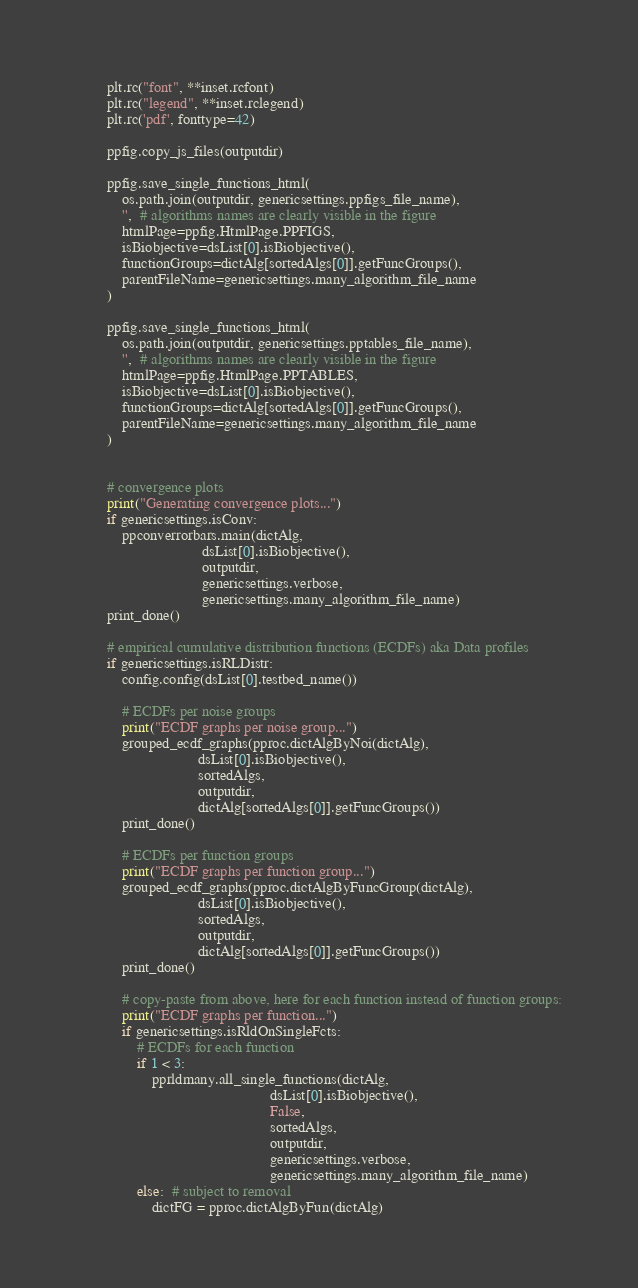<code> <loc_0><loc_0><loc_500><loc_500><_Python_>        plt.rc("font", **inset.rcfont)
        plt.rc("legend", **inset.rclegend)
        plt.rc('pdf', fonttype=42)

        ppfig.copy_js_files(outputdir)

        ppfig.save_single_functions_html(
            os.path.join(outputdir, genericsettings.ppfigs_file_name),
            '',  # algorithms names are clearly visible in the figure
            htmlPage=ppfig.HtmlPage.PPFIGS,
            isBiobjective=dsList[0].isBiobjective(),
            functionGroups=dictAlg[sortedAlgs[0]].getFuncGroups(),
            parentFileName=genericsettings.many_algorithm_file_name
        )

        ppfig.save_single_functions_html(
            os.path.join(outputdir, genericsettings.pptables_file_name),
            '',  # algorithms names are clearly visible in the figure
            htmlPage=ppfig.HtmlPage.PPTABLES,
            isBiobjective=dsList[0].isBiobjective(),
            functionGroups=dictAlg[sortedAlgs[0]].getFuncGroups(),
            parentFileName=genericsettings.many_algorithm_file_name
        )


        # convergence plots
        print("Generating convergence plots...")
        if genericsettings.isConv:
            ppconverrorbars.main(dictAlg,
                                 dsList[0].isBiobjective(),
                                 outputdir,
                                 genericsettings.verbose,
                                 genericsettings.many_algorithm_file_name)
        print_done()

        # empirical cumulative distribution functions (ECDFs) aka Data profiles
        if genericsettings.isRLDistr:
            config.config(dsList[0].testbed_name())

            # ECDFs per noise groups
            print("ECDF graphs per noise group...")
            grouped_ecdf_graphs(pproc.dictAlgByNoi(dictAlg),
                                dsList[0].isBiobjective(),
                                sortedAlgs,
                                outputdir,
                                dictAlg[sortedAlgs[0]].getFuncGroups())
            print_done()

            # ECDFs per function groups
            print("ECDF graphs per function group...")
            grouped_ecdf_graphs(pproc.dictAlgByFuncGroup(dictAlg),
                                dsList[0].isBiobjective(),
                                sortedAlgs,
                                outputdir,
                                dictAlg[sortedAlgs[0]].getFuncGroups())
            print_done()

            # copy-paste from above, here for each function instead of function groups:
            print("ECDF graphs per function...")
            if genericsettings.isRldOnSingleFcts:
                # ECDFs for each function
                if 1 < 3:
                    pprldmany.all_single_functions(dictAlg,
                                                   dsList[0].isBiobjective(),
                                                   False,
                                                   sortedAlgs,
                                                   outputdir,
                                                   genericsettings.verbose,
                                                   genericsettings.many_algorithm_file_name)
                else:  # subject to removal
                    dictFG = pproc.dictAlgByFun(dictAlg)</code> 